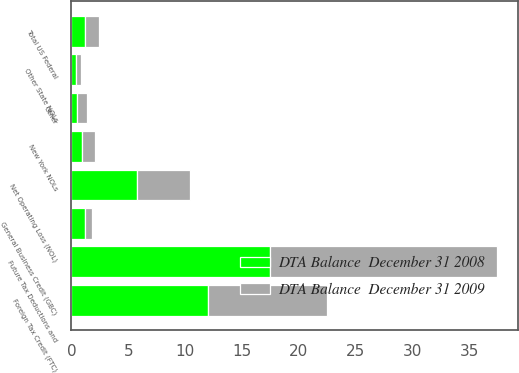Convert chart to OTSL. <chart><loc_0><loc_0><loc_500><loc_500><stacked_bar_chart><ecel><fcel>Net Operating Loss (NOL)<fcel>Foreign Tax Credit (FTC)<fcel>General Business Credit (GBC)<fcel>Future Tax Deductions and<fcel>Other<fcel>Total US Federal<fcel>New York NOLs<fcel>Other State NOLs<nl><fcel>DTA Balance  December 31 2008<fcel>5.8<fcel>12<fcel>1.2<fcel>17.5<fcel>0.5<fcel>1.2<fcel>0.9<fcel>0.4<nl><fcel>DTA Balance  December 31 2009<fcel>4.6<fcel>10.5<fcel>0.6<fcel>19.9<fcel>0.9<fcel>1.2<fcel>1.2<fcel>0.4<nl></chart> 